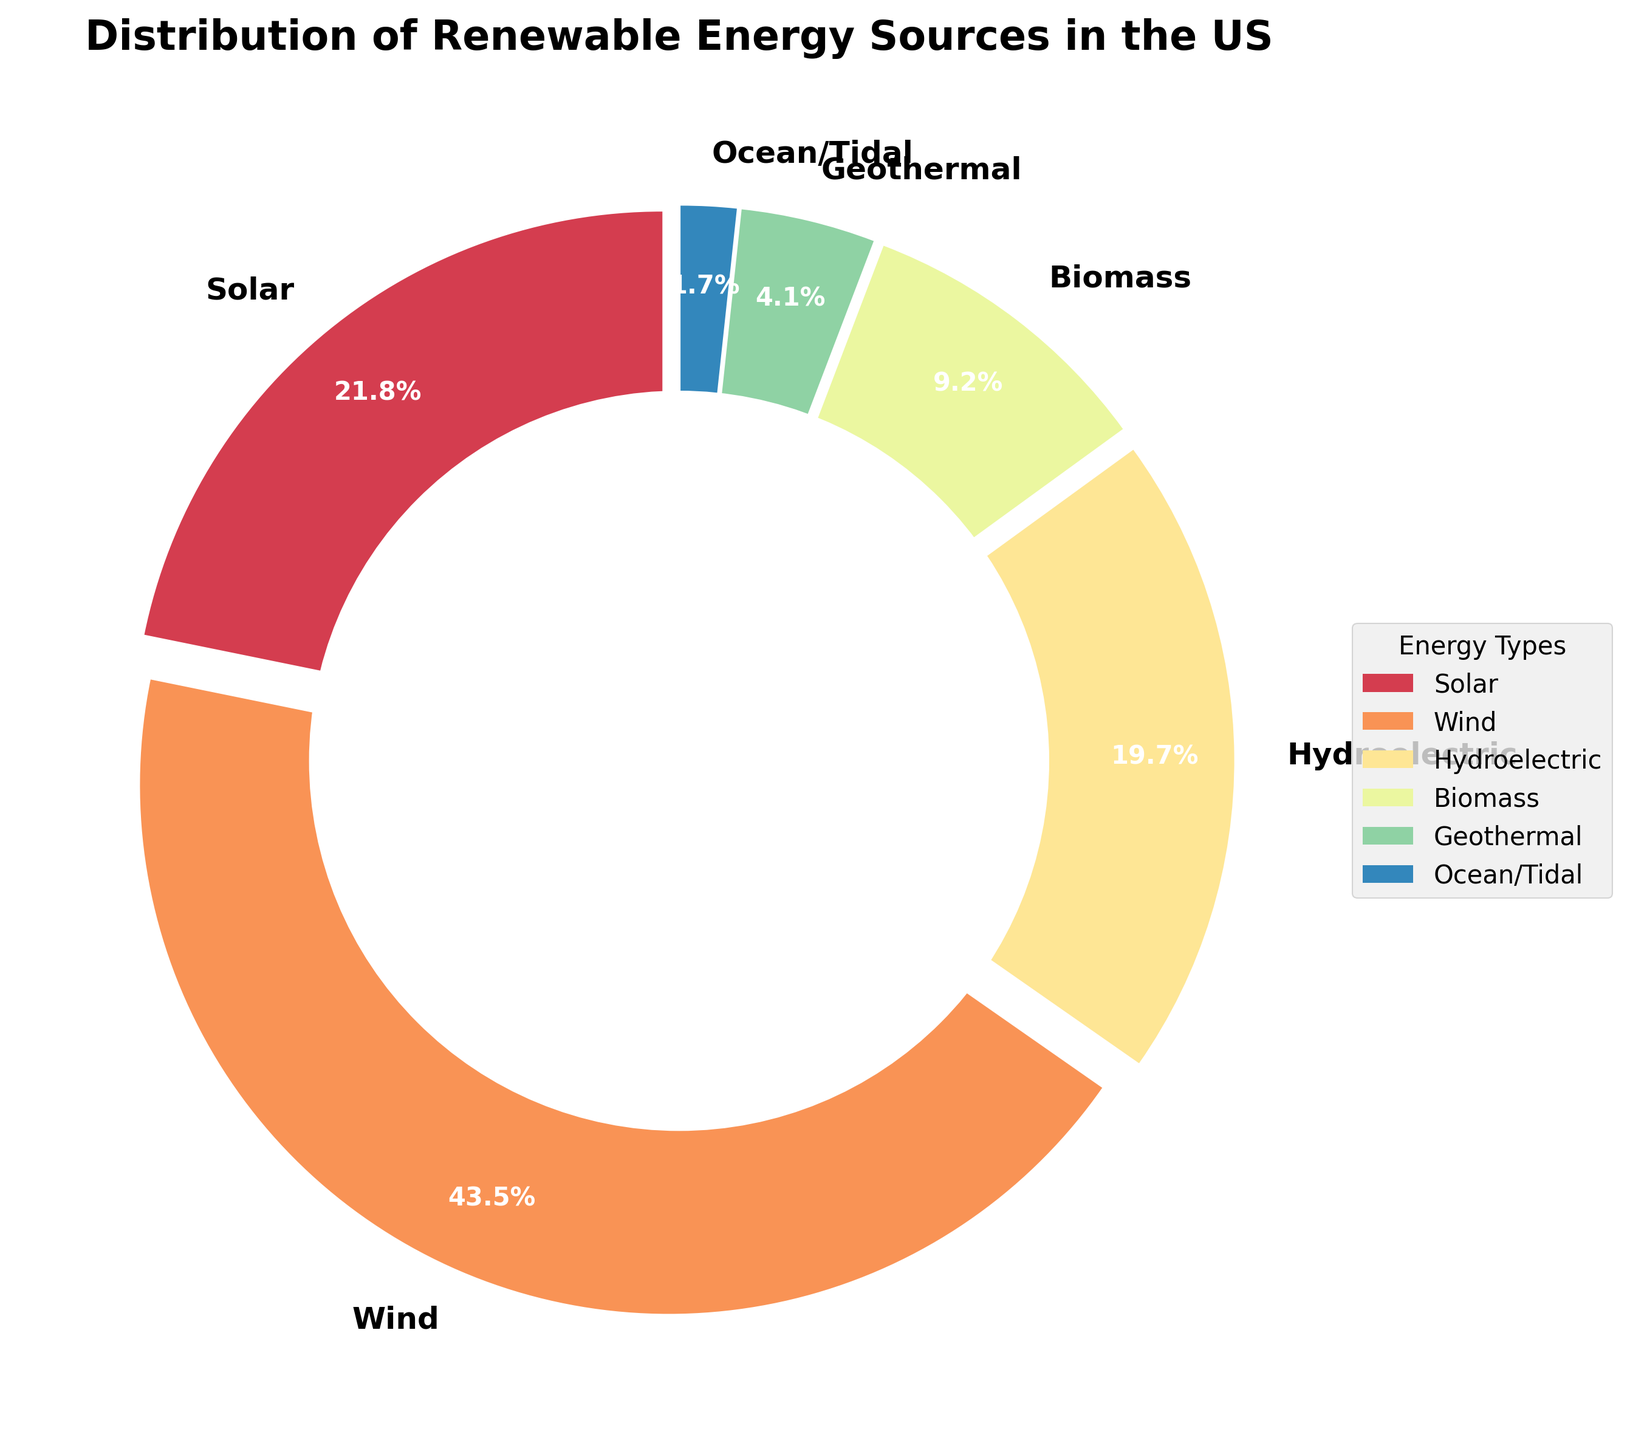What percentage of renewable energy comes from Solar and Wind combined? To find the combined percentage of Solar and Wind energy, add their individual percentages: Solar (21.8%) + Wind (43.5%) = 65.3%
Answer: 65.3% Which renewable energy source has the second-highest percentage? Look at the pie chart and identify the energy source with the second-largest wedge. Solar energy is the second-largest with 21.8%.
Answer: Solar Which two renewable energy sources combined make up just under half of the total renewable energy? Add the percentages of potential combinations of two sources and identify those near 50%. Wind (43.5%) + Hydroelectric (19.7%) = 63.2%, Solar (21.8%) + Hydroelectric (19.7%) = 41.5%, Solar (21.8%) + Wind (43.5%) = 65.3%. Therefore, Solar and Hydroelectric combined make up 41.5%, which is just under 50%.
Answer: Solar and Hydroelectric How much more percentage of energy does Wind contribute compared to Biomass? Subtract the percentage of Biomass from the percentage of Wind: Wind (43.5%) - Biomass (9.2%) = 34.3%
Answer: 34.3% What's the least utilized renewable energy source according to the chart? Identify the smallest wedge in the pie chart, which corresponds to the least percentage. Ocean/Tidal energy is the smallest at 1.7%.
Answer: Ocean/Tidal Do Wind and Geothermal energies together make up more than 45% of the total? Add the percentages of Wind and Geothermal energies: Wind (43.5%) + Geothermal (4.1%) = 47.6%. Since 47.6% is more than 45%, the answer is yes.
Answer: Yes Which energy source contributes almost the same percentage as the sum of Geothermal and Ocean/Tidal? Add the percentages of Geothermal (4.1%) and Ocean/Tidal (1.7%): 4.1% + 1.7% = 5.8%. Biomass (9.2%) does not meet this. So no single type closely matches this sum's percentage.
Answer: None What is the difference in the percentage of contribution between the highest and the lowest renewable energy sources? Subtract the percentage of the lowest (Ocean/Tidal, 1.7%) from the highest (Wind, 43.5%): 43.5% - 1.7% = 41.8%
Answer: 41.8% How many energy sources contribute less than 10% each? Look at the pie chart and count the wedges representing less than 10%. Biomass (9.2%), Geothermal (4.1%), and Ocean/Tidal (1.7%). There are three sources contributing less than 10%.
Answer: 3 